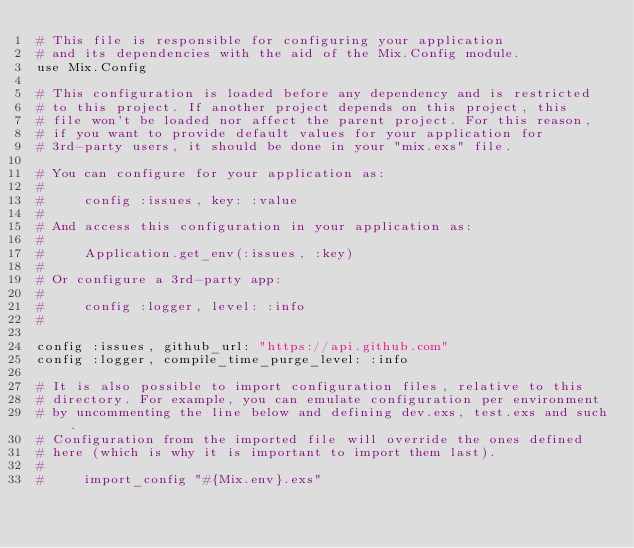<code> <loc_0><loc_0><loc_500><loc_500><_Elixir_># This file is responsible for configuring your application
# and its dependencies with the aid of the Mix.Config module.
use Mix.Config

# This configuration is loaded before any dependency and is restricted
# to this project. If another project depends on this project, this
# file won't be loaded nor affect the parent project. For this reason,
# if you want to provide default values for your application for
# 3rd-party users, it should be done in your "mix.exs" file.

# You can configure for your application as:
#
#     config :issues, key: :value
#
# And access this configuration in your application as:
#
#     Application.get_env(:issues, :key)
#
# Or configure a 3rd-party app:
#
#     config :logger, level: :info
#

config :issues, github_url: "https://api.github.com"
config :logger, compile_time_purge_level: :info

# It is also possible to import configuration files, relative to this
# directory. For example, you can emulate configuration per environment
# by uncommenting the line below and defining dev.exs, test.exs and such.
# Configuration from the imported file will override the ones defined
# here (which is why it is important to import them last).
#
#     import_config "#{Mix.env}.exs"
</code> 